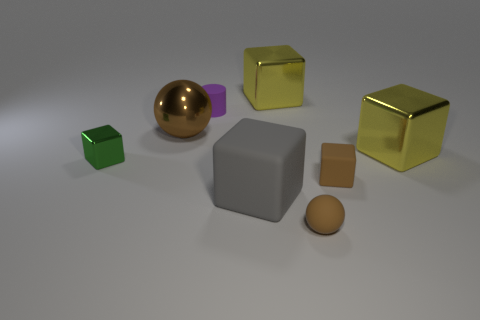Which object stands out the most to you, and why? The golden sphere stands out due to its reflective surface and distinct spherical shape amongst mostly angular objects. 